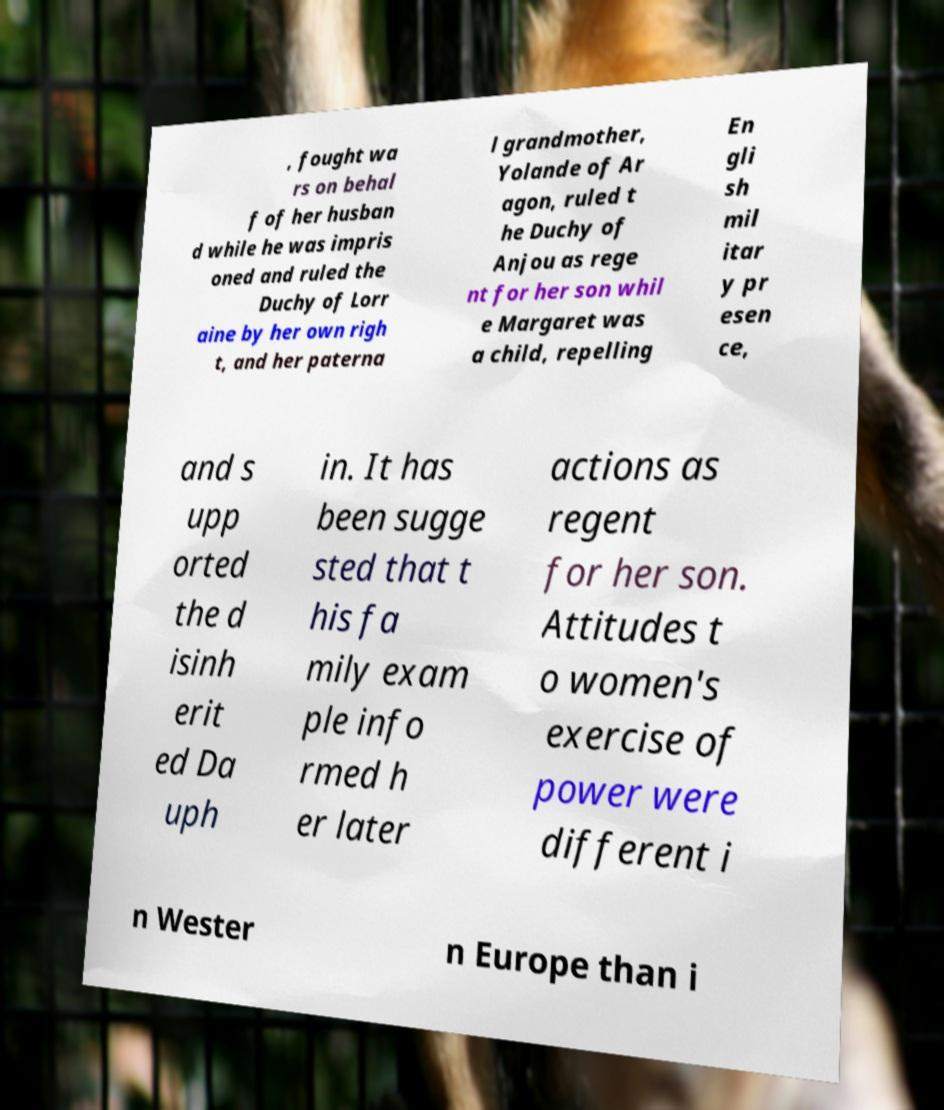Please read and relay the text visible in this image. What does it say? , fought wa rs on behal f of her husban d while he was impris oned and ruled the Duchy of Lorr aine by her own righ t, and her paterna l grandmother, Yolande of Ar agon, ruled t he Duchy of Anjou as rege nt for her son whil e Margaret was a child, repelling En gli sh mil itar y pr esen ce, and s upp orted the d isinh erit ed Da uph in. It has been sugge sted that t his fa mily exam ple info rmed h er later actions as regent for her son. Attitudes t o women's exercise of power were different i n Wester n Europe than i 